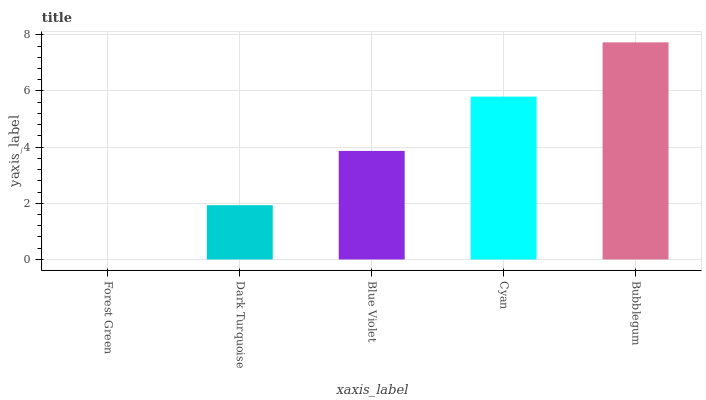Is Forest Green the minimum?
Answer yes or no. Yes. Is Bubblegum the maximum?
Answer yes or no. Yes. Is Dark Turquoise the minimum?
Answer yes or no. No. Is Dark Turquoise the maximum?
Answer yes or no. No. Is Dark Turquoise greater than Forest Green?
Answer yes or no. Yes. Is Forest Green less than Dark Turquoise?
Answer yes or no. Yes. Is Forest Green greater than Dark Turquoise?
Answer yes or no. No. Is Dark Turquoise less than Forest Green?
Answer yes or no. No. Is Blue Violet the high median?
Answer yes or no. Yes. Is Blue Violet the low median?
Answer yes or no. Yes. Is Bubblegum the high median?
Answer yes or no. No. Is Cyan the low median?
Answer yes or no. No. 